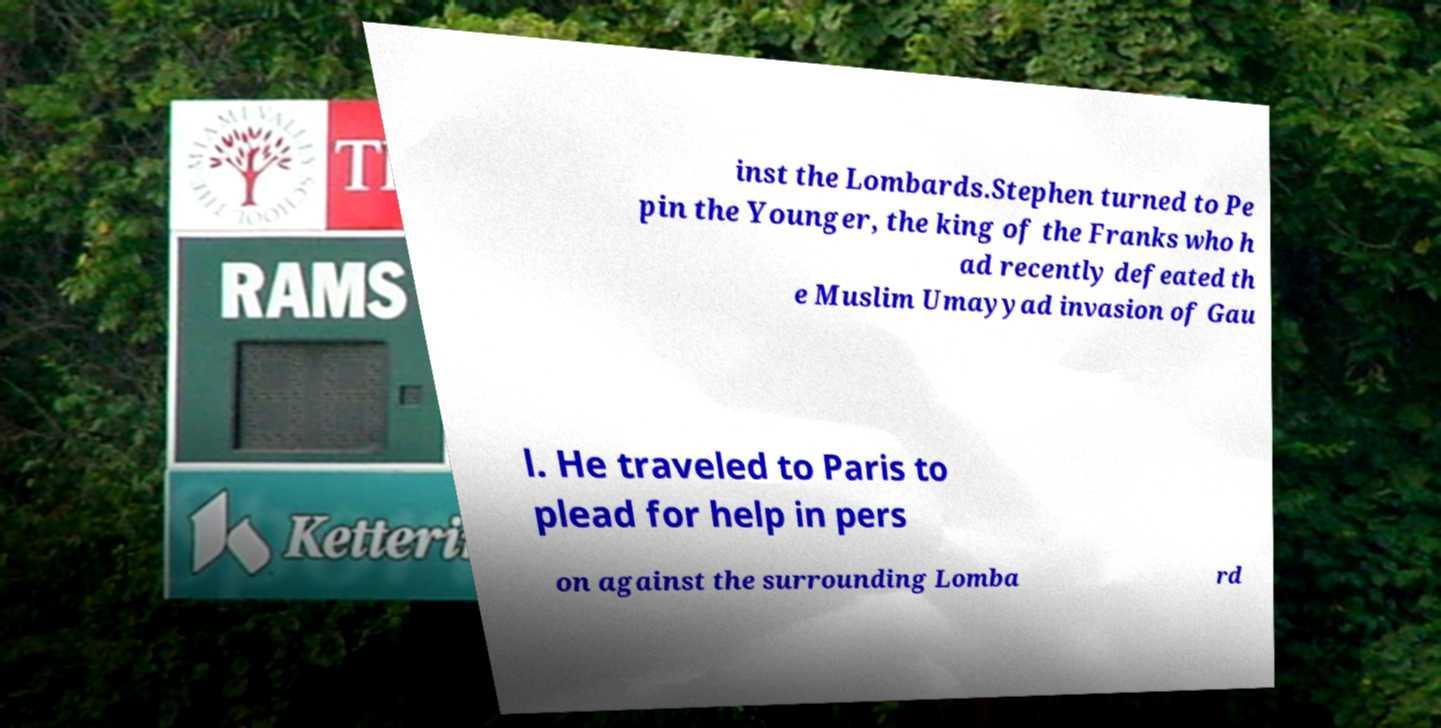There's text embedded in this image that I need extracted. Can you transcribe it verbatim? inst the Lombards.Stephen turned to Pe pin the Younger, the king of the Franks who h ad recently defeated th e Muslim Umayyad invasion of Gau l. He traveled to Paris to plead for help in pers on against the surrounding Lomba rd 